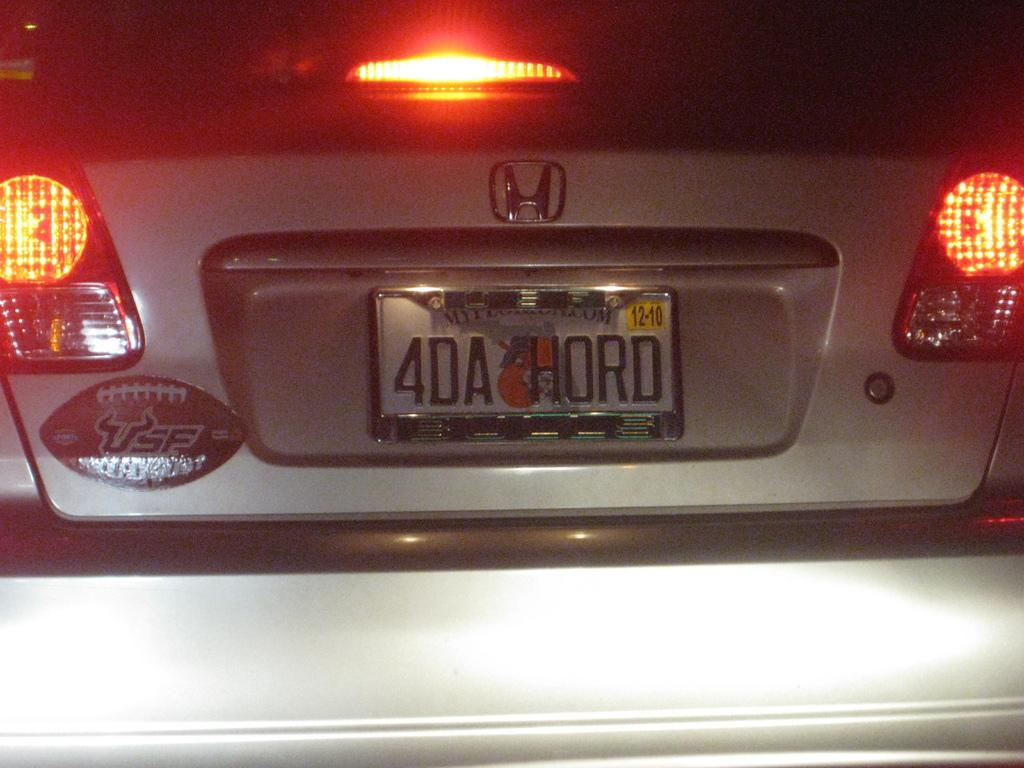<image>
Summarize the visual content of the image. A silver Honda Civic with a USF football sticker and a license plate that reads 4DA HORD. 